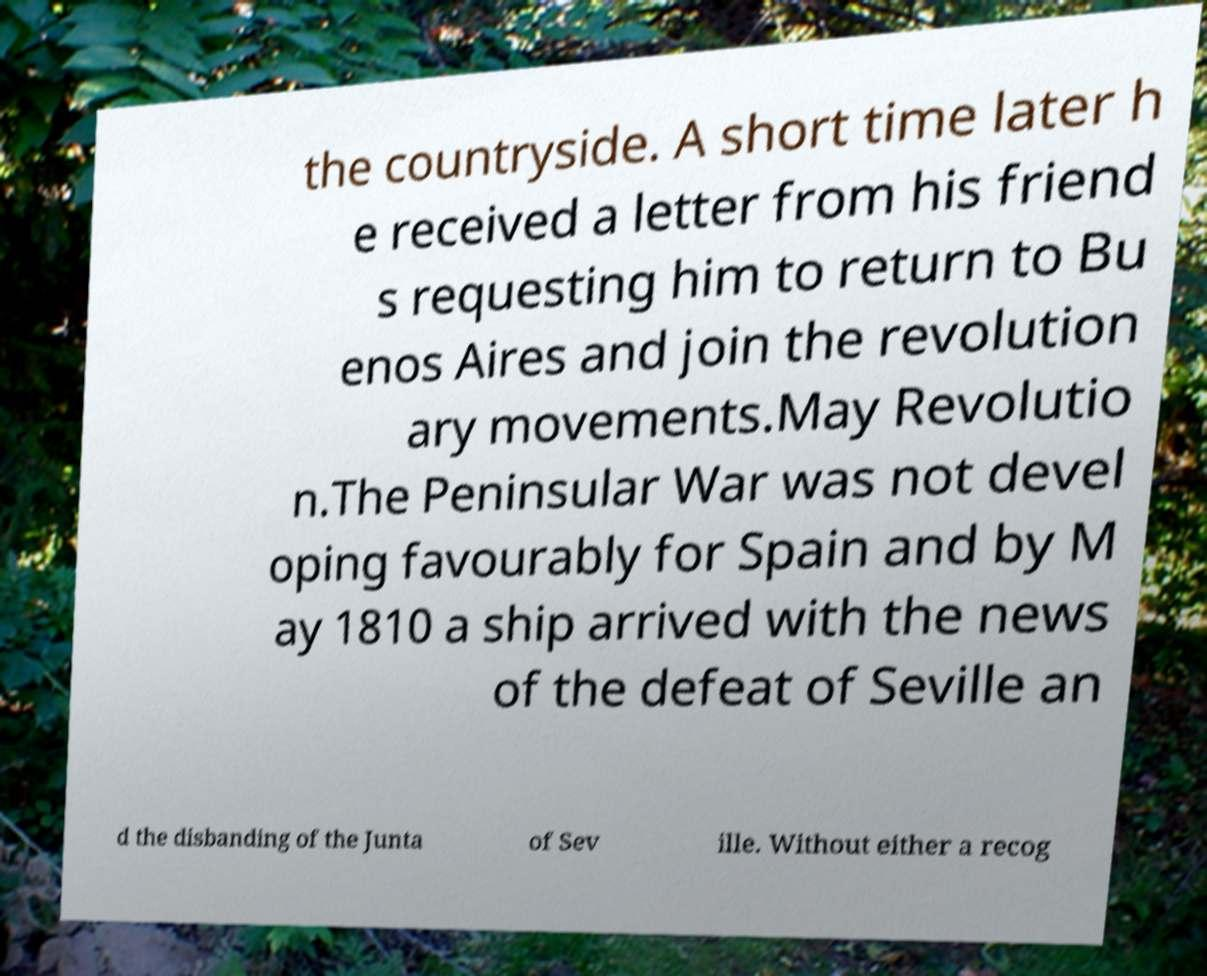What messages or text are displayed in this image? I need them in a readable, typed format. the countryside. A short time later h e received a letter from his friend s requesting him to return to Bu enos Aires and join the revolution ary movements.May Revolutio n.The Peninsular War was not devel oping favourably for Spain and by M ay 1810 a ship arrived with the news of the defeat of Seville an d the disbanding of the Junta of Sev ille. Without either a recog 